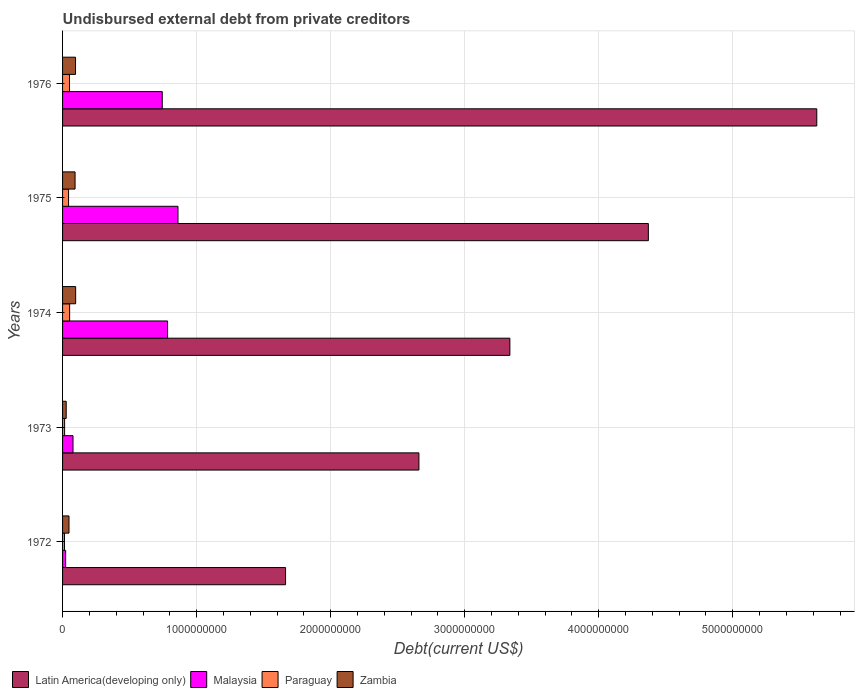Are the number of bars per tick equal to the number of legend labels?
Ensure brevity in your answer.  Yes. How many bars are there on the 3rd tick from the top?
Make the answer very short. 4. What is the label of the 4th group of bars from the top?
Make the answer very short. 1973. What is the total debt in Paraguay in 1976?
Your answer should be compact. 5.19e+07. Across all years, what is the maximum total debt in Malaysia?
Offer a terse response. 8.61e+08. Across all years, what is the minimum total debt in Malaysia?
Offer a very short reply. 2.31e+07. In which year was the total debt in Malaysia maximum?
Provide a succinct answer. 1975. In which year was the total debt in Zambia minimum?
Offer a terse response. 1973. What is the total total debt in Zambia in the graph?
Provide a succinct answer. 3.63e+08. What is the difference between the total debt in Malaysia in 1972 and that in 1975?
Keep it short and to the point. -8.38e+08. What is the difference between the total debt in Zambia in 1975 and the total debt in Paraguay in 1972?
Provide a short and direct response. 7.89e+07. What is the average total debt in Malaysia per year?
Provide a short and direct response. 4.98e+08. In the year 1976, what is the difference between the total debt in Malaysia and total debt in Zambia?
Give a very brief answer. 6.47e+08. In how many years, is the total debt in Paraguay greater than 3400000000 US$?
Provide a short and direct response. 0. What is the ratio of the total debt in Zambia in 1974 to that in 1975?
Make the answer very short. 1.05. Is the total debt in Paraguay in 1975 less than that in 1976?
Give a very brief answer. Yes. What is the difference between the highest and the second highest total debt in Paraguay?
Keep it short and to the point. 9.37e+05. What is the difference between the highest and the lowest total debt in Paraguay?
Provide a short and direct response. 3.85e+07. What does the 2nd bar from the top in 1975 represents?
Give a very brief answer. Paraguay. What does the 1st bar from the bottom in 1976 represents?
Your response must be concise. Latin America(developing only). Is it the case that in every year, the sum of the total debt in Malaysia and total debt in Paraguay is greater than the total debt in Zambia?
Offer a terse response. No. How many bars are there?
Your answer should be very brief. 20. Are the values on the major ticks of X-axis written in scientific E-notation?
Ensure brevity in your answer.  No. Where does the legend appear in the graph?
Your response must be concise. Bottom left. How many legend labels are there?
Your response must be concise. 4. How are the legend labels stacked?
Give a very brief answer. Horizontal. What is the title of the graph?
Provide a succinct answer. Undisbursed external debt from private creditors. What is the label or title of the X-axis?
Offer a very short reply. Debt(current US$). What is the Debt(current US$) in Latin America(developing only) in 1972?
Ensure brevity in your answer.  1.66e+09. What is the Debt(current US$) in Malaysia in 1972?
Your answer should be very brief. 2.31e+07. What is the Debt(current US$) in Paraguay in 1972?
Provide a succinct answer. 1.43e+07. What is the Debt(current US$) in Zambia in 1972?
Offer a terse response. 4.80e+07. What is the Debt(current US$) of Latin America(developing only) in 1973?
Offer a terse response. 2.66e+09. What is the Debt(current US$) of Malaysia in 1973?
Your answer should be very brief. 7.79e+07. What is the Debt(current US$) of Paraguay in 1973?
Your answer should be compact. 1.52e+07. What is the Debt(current US$) in Zambia in 1973?
Provide a succinct answer. 2.71e+07. What is the Debt(current US$) of Latin America(developing only) in 1974?
Your response must be concise. 3.34e+09. What is the Debt(current US$) in Malaysia in 1974?
Offer a terse response. 7.83e+08. What is the Debt(current US$) of Paraguay in 1974?
Offer a terse response. 5.28e+07. What is the Debt(current US$) of Zambia in 1974?
Provide a short and direct response. 9.76e+07. What is the Debt(current US$) in Latin America(developing only) in 1975?
Provide a short and direct response. 4.37e+09. What is the Debt(current US$) of Malaysia in 1975?
Your response must be concise. 8.61e+08. What is the Debt(current US$) in Paraguay in 1975?
Keep it short and to the point. 4.47e+07. What is the Debt(current US$) in Zambia in 1975?
Your answer should be compact. 9.32e+07. What is the Debt(current US$) in Latin America(developing only) in 1976?
Provide a succinct answer. 5.63e+09. What is the Debt(current US$) of Malaysia in 1976?
Provide a succinct answer. 7.44e+08. What is the Debt(current US$) in Paraguay in 1976?
Offer a terse response. 5.19e+07. What is the Debt(current US$) in Zambia in 1976?
Provide a short and direct response. 9.68e+07. Across all years, what is the maximum Debt(current US$) of Latin America(developing only)?
Your answer should be very brief. 5.63e+09. Across all years, what is the maximum Debt(current US$) in Malaysia?
Provide a short and direct response. 8.61e+08. Across all years, what is the maximum Debt(current US$) in Paraguay?
Make the answer very short. 5.28e+07. Across all years, what is the maximum Debt(current US$) of Zambia?
Give a very brief answer. 9.76e+07. Across all years, what is the minimum Debt(current US$) in Latin America(developing only)?
Provide a short and direct response. 1.66e+09. Across all years, what is the minimum Debt(current US$) in Malaysia?
Make the answer very short. 2.31e+07. Across all years, what is the minimum Debt(current US$) of Paraguay?
Provide a succinct answer. 1.43e+07. Across all years, what is the minimum Debt(current US$) of Zambia?
Make the answer very short. 2.71e+07. What is the total Debt(current US$) of Latin America(developing only) in the graph?
Offer a terse response. 1.77e+1. What is the total Debt(current US$) of Malaysia in the graph?
Your response must be concise. 2.49e+09. What is the total Debt(current US$) in Paraguay in the graph?
Keep it short and to the point. 1.79e+08. What is the total Debt(current US$) in Zambia in the graph?
Give a very brief answer. 3.63e+08. What is the difference between the Debt(current US$) in Latin America(developing only) in 1972 and that in 1973?
Provide a short and direct response. -9.95e+08. What is the difference between the Debt(current US$) in Malaysia in 1972 and that in 1973?
Your answer should be very brief. -5.49e+07. What is the difference between the Debt(current US$) of Paraguay in 1972 and that in 1973?
Offer a terse response. -8.94e+05. What is the difference between the Debt(current US$) of Zambia in 1972 and that in 1973?
Give a very brief answer. 2.08e+07. What is the difference between the Debt(current US$) in Latin America(developing only) in 1972 and that in 1974?
Ensure brevity in your answer.  -1.67e+09. What is the difference between the Debt(current US$) of Malaysia in 1972 and that in 1974?
Offer a very short reply. -7.60e+08. What is the difference between the Debt(current US$) in Paraguay in 1972 and that in 1974?
Offer a very short reply. -3.85e+07. What is the difference between the Debt(current US$) in Zambia in 1972 and that in 1974?
Your response must be concise. -4.96e+07. What is the difference between the Debt(current US$) of Latin America(developing only) in 1972 and that in 1975?
Offer a terse response. -2.71e+09. What is the difference between the Debt(current US$) of Malaysia in 1972 and that in 1975?
Give a very brief answer. -8.38e+08. What is the difference between the Debt(current US$) in Paraguay in 1972 and that in 1975?
Ensure brevity in your answer.  -3.04e+07. What is the difference between the Debt(current US$) of Zambia in 1972 and that in 1975?
Your response must be concise. -4.52e+07. What is the difference between the Debt(current US$) in Latin America(developing only) in 1972 and that in 1976?
Ensure brevity in your answer.  -3.96e+09. What is the difference between the Debt(current US$) in Malaysia in 1972 and that in 1976?
Keep it short and to the point. -7.21e+08. What is the difference between the Debt(current US$) of Paraguay in 1972 and that in 1976?
Provide a succinct answer. -3.75e+07. What is the difference between the Debt(current US$) of Zambia in 1972 and that in 1976?
Your response must be concise. -4.88e+07. What is the difference between the Debt(current US$) of Latin America(developing only) in 1973 and that in 1974?
Offer a terse response. -6.79e+08. What is the difference between the Debt(current US$) in Malaysia in 1973 and that in 1974?
Your answer should be compact. -7.06e+08. What is the difference between the Debt(current US$) of Paraguay in 1973 and that in 1974?
Make the answer very short. -3.76e+07. What is the difference between the Debt(current US$) in Zambia in 1973 and that in 1974?
Your answer should be very brief. -7.05e+07. What is the difference between the Debt(current US$) in Latin America(developing only) in 1973 and that in 1975?
Ensure brevity in your answer.  -1.71e+09. What is the difference between the Debt(current US$) of Malaysia in 1973 and that in 1975?
Your answer should be compact. -7.83e+08. What is the difference between the Debt(current US$) of Paraguay in 1973 and that in 1975?
Ensure brevity in your answer.  -2.95e+07. What is the difference between the Debt(current US$) of Zambia in 1973 and that in 1975?
Ensure brevity in your answer.  -6.61e+07. What is the difference between the Debt(current US$) of Latin America(developing only) in 1973 and that in 1976?
Provide a short and direct response. -2.97e+09. What is the difference between the Debt(current US$) in Malaysia in 1973 and that in 1976?
Make the answer very short. -6.66e+08. What is the difference between the Debt(current US$) of Paraguay in 1973 and that in 1976?
Offer a terse response. -3.66e+07. What is the difference between the Debt(current US$) in Zambia in 1973 and that in 1976?
Provide a short and direct response. -6.96e+07. What is the difference between the Debt(current US$) in Latin America(developing only) in 1974 and that in 1975?
Your response must be concise. -1.03e+09. What is the difference between the Debt(current US$) of Malaysia in 1974 and that in 1975?
Your answer should be very brief. -7.76e+07. What is the difference between the Debt(current US$) of Paraguay in 1974 and that in 1975?
Provide a succinct answer. 8.11e+06. What is the difference between the Debt(current US$) in Zambia in 1974 and that in 1975?
Provide a succinct answer. 4.40e+06. What is the difference between the Debt(current US$) of Latin America(developing only) in 1974 and that in 1976?
Give a very brief answer. -2.29e+09. What is the difference between the Debt(current US$) in Malaysia in 1974 and that in 1976?
Keep it short and to the point. 3.96e+07. What is the difference between the Debt(current US$) of Paraguay in 1974 and that in 1976?
Give a very brief answer. 9.37e+05. What is the difference between the Debt(current US$) of Zambia in 1974 and that in 1976?
Your answer should be very brief. 8.46e+05. What is the difference between the Debt(current US$) of Latin America(developing only) in 1975 and that in 1976?
Ensure brevity in your answer.  -1.26e+09. What is the difference between the Debt(current US$) of Malaysia in 1975 and that in 1976?
Your answer should be compact. 1.17e+08. What is the difference between the Debt(current US$) in Paraguay in 1975 and that in 1976?
Your answer should be compact. -7.18e+06. What is the difference between the Debt(current US$) of Zambia in 1975 and that in 1976?
Your answer should be very brief. -3.55e+06. What is the difference between the Debt(current US$) of Latin America(developing only) in 1972 and the Debt(current US$) of Malaysia in 1973?
Your answer should be very brief. 1.59e+09. What is the difference between the Debt(current US$) of Latin America(developing only) in 1972 and the Debt(current US$) of Paraguay in 1973?
Provide a short and direct response. 1.65e+09. What is the difference between the Debt(current US$) of Latin America(developing only) in 1972 and the Debt(current US$) of Zambia in 1973?
Your answer should be compact. 1.64e+09. What is the difference between the Debt(current US$) of Malaysia in 1972 and the Debt(current US$) of Paraguay in 1973?
Make the answer very short. 7.84e+06. What is the difference between the Debt(current US$) of Malaysia in 1972 and the Debt(current US$) of Zambia in 1973?
Provide a short and direct response. -4.05e+06. What is the difference between the Debt(current US$) of Paraguay in 1972 and the Debt(current US$) of Zambia in 1973?
Ensure brevity in your answer.  -1.28e+07. What is the difference between the Debt(current US$) of Latin America(developing only) in 1972 and the Debt(current US$) of Malaysia in 1974?
Give a very brief answer. 8.80e+08. What is the difference between the Debt(current US$) in Latin America(developing only) in 1972 and the Debt(current US$) in Paraguay in 1974?
Offer a terse response. 1.61e+09. What is the difference between the Debt(current US$) in Latin America(developing only) in 1972 and the Debt(current US$) in Zambia in 1974?
Ensure brevity in your answer.  1.57e+09. What is the difference between the Debt(current US$) of Malaysia in 1972 and the Debt(current US$) of Paraguay in 1974?
Keep it short and to the point. -2.97e+07. What is the difference between the Debt(current US$) of Malaysia in 1972 and the Debt(current US$) of Zambia in 1974?
Offer a very short reply. -7.45e+07. What is the difference between the Debt(current US$) of Paraguay in 1972 and the Debt(current US$) of Zambia in 1974?
Offer a terse response. -8.33e+07. What is the difference between the Debt(current US$) in Latin America(developing only) in 1972 and the Debt(current US$) in Malaysia in 1975?
Give a very brief answer. 8.03e+08. What is the difference between the Debt(current US$) of Latin America(developing only) in 1972 and the Debt(current US$) of Paraguay in 1975?
Give a very brief answer. 1.62e+09. What is the difference between the Debt(current US$) of Latin America(developing only) in 1972 and the Debt(current US$) of Zambia in 1975?
Offer a very short reply. 1.57e+09. What is the difference between the Debt(current US$) in Malaysia in 1972 and the Debt(current US$) in Paraguay in 1975?
Your answer should be very brief. -2.16e+07. What is the difference between the Debt(current US$) in Malaysia in 1972 and the Debt(current US$) in Zambia in 1975?
Offer a very short reply. -7.01e+07. What is the difference between the Debt(current US$) of Paraguay in 1972 and the Debt(current US$) of Zambia in 1975?
Give a very brief answer. -7.89e+07. What is the difference between the Debt(current US$) of Latin America(developing only) in 1972 and the Debt(current US$) of Malaysia in 1976?
Keep it short and to the point. 9.20e+08. What is the difference between the Debt(current US$) in Latin America(developing only) in 1972 and the Debt(current US$) in Paraguay in 1976?
Provide a succinct answer. 1.61e+09. What is the difference between the Debt(current US$) of Latin America(developing only) in 1972 and the Debt(current US$) of Zambia in 1976?
Your response must be concise. 1.57e+09. What is the difference between the Debt(current US$) in Malaysia in 1972 and the Debt(current US$) in Paraguay in 1976?
Provide a succinct answer. -2.88e+07. What is the difference between the Debt(current US$) of Malaysia in 1972 and the Debt(current US$) of Zambia in 1976?
Your answer should be compact. -7.37e+07. What is the difference between the Debt(current US$) in Paraguay in 1972 and the Debt(current US$) in Zambia in 1976?
Your answer should be compact. -8.24e+07. What is the difference between the Debt(current US$) of Latin America(developing only) in 1973 and the Debt(current US$) of Malaysia in 1974?
Offer a terse response. 1.88e+09. What is the difference between the Debt(current US$) in Latin America(developing only) in 1973 and the Debt(current US$) in Paraguay in 1974?
Ensure brevity in your answer.  2.61e+09. What is the difference between the Debt(current US$) of Latin America(developing only) in 1973 and the Debt(current US$) of Zambia in 1974?
Keep it short and to the point. 2.56e+09. What is the difference between the Debt(current US$) in Malaysia in 1973 and the Debt(current US$) in Paraguay in 1974?
Ensure brevity in your answer.  2.51e+07. What is the difference between the Debt(current US$) of Malaysia in 1973 and the Debt(current US$) of Zambia in 1974?
Provide a succinct answer. -1.97e+07. What is the difference between the Debt(current US$) of Paraguay in 1973 and the Debt(current US$) of Zambia in 1974?
Your response must be concise. -8.24e+07. What is the difference between the Debt(current US$) of Latin America(developing only) in 1973 and the Debt(current US$) of Malaysia in 1975?
Provide a short and direct response. 1.80e+09. What is the difference between the Debt(current US$) of Latin America(developing only) in 1973 and the Debt(current US$) of Paraguay in 1975?
Provide a short and direct response. 2.61e+09. What is the difference between the Debt(current US$) in Latin America(developing only) in 1973 and the Debt(current US$) in Zambia in 1975?
Offer a very short reply. 2.57e+09. What is the difference between the Debt(current US$) of Malaysia in 1973 and the Debt(current US$) of Paraguay in 1975?
Offer a terse response. 3.32e+07. What is the difference between the Debt(current US$) in Malaysia in 1973 and the Debt(current US$) in Zambia in 1975?
Your response must be concise. -1.53e+07. What is the difference between the Debt(current US$) in Paraguay in 1973 and the Debt(current US$) in Zambia in 1975?
Provide a short and direct response. -7.80e+07. What is the difference between the Debt(current US$) of Latin America(developing only) in 1973 and the Debt(current US$) of Malaysia in 1976?
Keep it short and to the point. 1.91e+09. What is the difference between the Debt(current US$) of Latin America(developing only) in 1973 and the Debt(current US$) of Paraguay in 1976?
Give a very brief answer. 2.61e+09. What is the difference between the Debt(current US$) of Latin America(developing only) in 1973 and the Debt(current US$) of Zambia in 1976?
Provide a succinct answer. 2.56e+09. What is the difference between the Debt(current US$) in Malaysia in 1973 and the Debt(current US$) in Paraguay in 1976?
Ensure brevity in your answer.  2.61e+07. What is the difference between the Debt(current US$) of Malaysia in 1973 and the Debt(current US$) of Zambia in 1976?
Offer a terse response. -1.88e+07. What is the difference between the Debt(current US$) in Paraguay in 1973 and the Debt(current US$) in Zambia in 1976?
Offer a terse response. -8.15e+07. What is the difference between the Debt(current US$) of Latin America(developing only) in 1974 and the Debt(current US$) of Malaysia in 1975?
Ensure brevity in your answer.  2.48e+09. What is the difference between the Debt(current US$) of Latin America(developing only) in 1974 and the Debt(current US$) of Paraguay in 1975?
Keep it short and to the point. 3.29e+09. What is the difference between the Debt(current US$) of Latin America(developing only) in 1974 and the Debt(current US$) of Zambia in 1975?
Your answer should be compact. 3.24e+09. What is the difference between the Debt(current US$) of Malaysia in 1974 and the Debt(current US$) of Paraguay in 1975?
Ensure brevity in your answer.  7.39e+08. What is the difference between the Debt(current US$) of Malaysia in 1974 and the Debt(current US$) of Zambia in 1975?
Make the answer very short. 6.90e+08. What is the difference between the Debt(current US$) of Paraguay in 1974 and the Debt(current US$) of Zambia in 1975?
Offer a very short reply. -4.04e+07. What is the difference between the Debt(current US$) of Latin America(developing only) in 1974 and the Debt(current US$) of Malaysia in 1976?
Give a very brief answer. 2.59e+09. What is the difference between the Debt(current US$) in Latin America(developing only) in 1974 and the Debt(current US$) in Paraguay in 1976?
Provide a succinct answer. 3.29e+09. What is the difference between the Debt(current US$) in Latin America(developing only) in 1974 and the Debt(current US$) in Zambia in 1976?
Give a very brief answer. 3.24e+09. What is the difference between the Debt(current US$) of Malaysia in 1974 and the Debt(current US$) of Paraguay in 1976?
Make the answer very short. 7.32e+08. What is the difference between the Debt(current US$) in Malaysia in 1974 and the Debt(current US$) in Zambia in 1976?
Provide a succinct answer. 6.87e+08. What is the difference between the Debt(current US$) in Paraguay in 1974 and the Debt(current US$) in Zambia in 1976?
Make the answer very short. -4.40e+07. What is the difference between the Debt(current US$) of Latin America(developing only) in 1975 and the Debt(current US$) of Malaysia in 1976?
Provide a short and direct response. 3.63e+09. What is the difference between the Debt(current US$) of Latin America(developing only) in 1975 and the Debt(current US$) of Paraguay in 1976?
Give a very brief answer. 4.32e+09. What is the difference between the Debt(current US$) of Latin America(developing only) in 1975 and the Debt(current US$) of Zambia in 1976?
Make the answer very short. 4.27e+09. What is the difference between the Debt(current US$) of Malaysia in 1975 and the Debt(current US$) of Paraguay in 1976?
Keep it short and to the point. 8.09e+08. What is the difference between the Debt(current US$) of Malaysia in 1975 and the Debt(current US$) of Zambia in 1976?
Provide a short and direct response. 7.64e+08. What is the difference between the Debt(current US$) in Paraguay in 1975 and the Debt(current US$) in Zambia in 1976?
Give a very brief answer. -5.21e+07. What is the average Debt(current US$) of Latin America(developing only) per year?
Your response must be concise. 3.53e+09. What is the average Debt(current US$) in Malaysia per year?
Your answer should be very brief. 4.98e+08. What is the average Debt(current US$) of Paraguay per year?
Your response must be concise. 3.58e+07. What is the average Debt(current US$) of Zambia per year?
Offer a very short reply. 7.25e+07. In the year 1972, what is the difference between the Debt(current US$) in Latin America(developing only) and Debt(current US$) in Malaysia?
Make the answer very short. 1.64e+09. In the year 1972, what is the difference between the Debt(current US$) in Latin America(developing only) and Debt(current US$) in Paraguay?
Provide a succinct answer. 1.65e+09. In the year 1972, what is the difference between the Debt(current US$) of Latin America(developing only) and Debt(current US$) of Zambia?
Give a very brief answer. 1.62e+09. In the year 1972, what is the difference between the Debt(current US$) of Malaysia and Debt(current US$) of Paraguay?
Your answer should be very brief. 8.74e+06. In the year 1972, what is the difference between the Debt(current US$) of Malaysia and Debt(current US$) of Zambia?
Give a very brief answer. -2.49e+07. In the year 1972, what is the difference between the Debt(current US$) in Paraguay and Debt(current US$) in Zambia?
Ensure brevity in your answer.  -3.36e+07. In the year 1973, what is the difference between the Debt(current US$) in Latin America(developing only) and Debt(current US$) in Malaysia?
Your answer should be compact. 2.58e+09. In the year 1973, what is the difference between the Debt(current US$) of Latin America(developing only) and Debt(current US$) of Paraguay?
Provide a short and direct response. 2.64e+09. In the year 1973, what is the difference between the Debt(current US$) in Latin America(developing only) and Debt(current US$) in Zambia?
Your answer should be very brief. 2.63e+09. In the year 1973, what is the difference between the Debt(current US$) in Malaysia and Debt(current US$) in Paraguay?
Provide a succinct answer. 6.27e+07. In the year 1973, what is the difference between the Debt(current US$) in Malaysia and Debt(current US$) in Zambia?
Give a very brief answer. 5.08e+07. In the year 1973, what is the difference between the Debt(current US$) in Paraguay and Debt(current US$) in Zambia?
Provide a short and direct response. -1.19e+07. In the year 1974, what is the difference between the Debt(current US$) in Latin America(developing only) and Debt(current US$) in Malaysia?
Give a very brief answer. 2.55e+09. In the year 1974, what is the difference between the Debt(current US$) in Latin America(developing only) and Debt(current US$) in Paraguay?
Your answer should be compact. 3.28e+09. In the year 1974, what is the difference between the Debt(current US$) of Latin America(developing only) and Debt(current US$) of Zambia?
Make the answer very short. 3.24e+09. In the year 1974, what is the difference between the Debt(current US$) of Malaysia and Debt(current US$) of Paraguay?
Make the answer very short. 7.31e+08. In the year 1974, what is the difference between the Debt(current US$) in Malaysia and Debt(current US$) in Zambia?
Your answer should be compact. 6.86e+08. In the year 1974, what is the difference between the Debt(current US$) in Paraguay and Debt(current US$) in Zambia?
Give a very brief answer. -4.48e+07. In the year 1975, what is the difference between the Debt(current US$) of Latin America(developing only) and Debt(current US$) of Malaysia?
Give a very brief answer. 3.51e+09. In the year 1975, what is the difference between the Debt(current US$) in Latin America(developing only) and Debt(current US$) in Paraguay?
Your answer should be very brief. 4.33e+09. In the year 1975, what is the difference between the Debt(current US$) of Latin America(developing only) and Debt(current US$) of Zambia?
Provide a succinct answer. 4.28e+09. In the year 1975, what is the difference between the Debt(current US$) of Malaysia and Debt(current US$) of Paraguay?
Offer a terse response. 8.16e+08. In the year 1975, what is the difference between the Debt(current US$) of Malaysia and Debt(current US$) of Zambia?
Offer a terse response. 7.68e+08. In the year 1975, what is the difference between the Debt(current US$) in Paraguay and Debt(current US$) in Zambia?
Give a very brief answer. -4.85e+07. In the year 1976, what is the difference between the Debt(current US$) in Latin America(developing only) and Debt(current US$) in Malaysia?
Keep it short and to the point. 4.88e+09. In the year 1976, what is the difference between the Debt(current US$) in Latin America(developing only) and Debt(current US$) in Paraguay?
Give a very brief answer. 5.57e+09. In the year 1976, what is the difference between the Debt(current US$) in Latin America(developing only) and Debt(current US$) in Zambia?
Give a very brief answer. 5.53e+09. In the year 1976, what is the difference between the Debt(current US$) of Malaysia and Debt(current US$) of Paraguay?
Give a very brief answer. 6.92e+08. In the year 1976, what is the difference between the Debt(current US$) in Malaysia and Debt(current US$) in Zambia?
Provide a short and direct response. 6.47e+08. In the year 1976, what is the difference between the Debt(current US$) in Paraguay and Debt(current US$) in Zambia?
Your answer should be compact. -4.49e+07. What is the ratio of the Debt(current US$) in Latin America(developing only) in 1972 to that in 1973?
Your answer should be very brief. 0.63. What is the ratio of the Debt(current US$) in Malaysia in 1972 to that in 1973?
Provide a succinct answer. 0.3. What is the ratio of the Debt(current US$) in Paraguay in 1972 to that in 1973?
Provide a succinct answer. 0.94. What is the ratio of the Debt(current US$) of Zambia in 1972 to that in 1973?
Offer a terse response. 1.77. What is the ratio of the Debt(current US$) in Latin America(developing only) in 1972 to that in 1974?
Your answer should be very brief. 0.5. What is the ratio of the Debt(current US$) in Malaysia in 1972 to that in 1974?
Your response must be concise. 0.03. What is the ratio of the Debt(current US$) of Paraguay in 1972 to that in 1974?
Offer a terse response. 0.27. What is the ratio of the Debt(current US$) of Zambia in 1972 to that in 1974?
Your answer should be compact. 0.49. What is the ratio of the Debt(current US$) of Latin America(developing only) in 1972 to that in 1975?
Ensure brevity in your answer.  0.38. What is the ratio of the Debt(current US$) of Malaysia in 1972 to that in 1975?
Make the answer very short. 0.03. What is the ratio of the Debt(current US$) of Paraguay in 1972 to that in 1975?
Offer a terse response. 0.32. What is the ratio of the Debt(current US$) in Zambia in 1972 to that in 1975?
Give a very brief answer. 0.51. What is the ratio of the Debt(current US$) in Latin America(developing only) in 1972 to that in 1976?
Your response must be concise. 0.3. What is the ratio of the Debt(current US$) in Malaysia in 1972 to that in 1976?
Your response must be concise. 0.03. What is the ratio of the Debt(current US$) in Paraguay in 1972 to that in 1976?
Keep it short and to the point. 0.28. What is the ratio of the Debt(current US$) in Zambia in 1972 to that in 1976?
Provide a succinct answer. 0.5. What is the ratio of the Debt(current US$) of Latin America(developing only) in 1973 to that in 1974?
Your response must be concise. 0.8. What is the ratio of the Debt(current US$) in Malaysia in 1973 to that in 1974?
Offer a terse response. 0.1. What is the ratio of the Debt(current US$) in Paraguay in 1973 to that in 1974?
Keep it short and to the point. 0.29. What is the ratio of the Debt(current US$) in Zambia in 1973 to that in 1974?
Provide a short and direct response. 0.28. What is the ratio of the Debt(current US$) of Latin America(developing only) in 1973 to that in 1975?
Provide a short and direct response. 0.61. What is the ratio of the Debt(current US$) in Malaysia in 1973 to that in 1975?
Provide a succinct answer. 0.09. What is the ratio of the Debt(current US$) in Paraguay in 1973 to that in 1975?
Offer a very short reply. 0.34. What is the ratio of the Debt(current US$) of Zambia in 1973 to that in 1975?
Provide a succinct answer. 0.29. What is the ratio of the Debt(current US$) in Latin America(developing only) in 1973 to that in 1976?
Your answer should be compact. 0.47. What is the ratio of the Debt(current US$) of Malaysia in 1973 to that in 1976?
Provide a short and direct response. 0.1. What is the ratio of the Debt(current US$) in Paraguay in 1973 to that in 1976?
Give a very brief answer. 0.29. What is the ratio of the Debt(current US$) in Zambia in 1973 to that in 1976?
Provide a succinct answer. 0.28. What is the ratio of the Debt(current US$) in Latin America(developing only) in 1974 to that in 1975?
Ensure brevity in your answer.  0.76. What is the ratio of the Debt(current US$) in Malaysia in 1974 to that in 1975?
Ensure brevity in your answer.  0.91. What is the ratio of the Debt(current US$) in Paraguay in 1974 to that in 1975?
Your answer should be compact. 1.18. What is the ratio of the Debt(current US$) of Zambia in 1974 to that in 1975?
Provide a short and direct response. 1.05. What is the ratio of the Debt(current US$) of Latin America(developing only) in 1974 to that in 1976?
Offer a very short reply. 0.59. What is the ratio of the Debt(current US$) in Malaysia in 1974 to that in 1976?
Offer a terse response. 1.05. What is the ratio of the Debt(current US$) in Paraguay in 1974 to that in 1976?
Offer a terse response. 1.02. What is the ratio of the Debt(current US$) of Zambia in 1974 to that in 1976?
Your answer should be compact. 1.01. What is the ratio of the Debt(current US$) of Latin America(developing only) in 1975 to that in 1976?
Keep it short and to the point. 0.78. What is the ratio of the Debt(current US$) in Malaysia in 1975 to that in 1976?
Provide a succinct answer. 1.16. What is the ratio of the Debt(current US$) in Paraguay in 1975 to that in 1976?
Your answer should be compact. 0.86. What is the ratio of the Debt(current US$) in Zambia in 1975 to that in 1976?
Your answer should be very brief. 0.96. What is the difference between the highest and the second highest Debt(current US$) of Latin America(developing only)?
Give a very brief answer. 1.26e+09. What is the difference between the highest and the second highest Debt(current US$) in Malaysia?
Your answer should be very brief. 7.76e+07. What is the difference between the highest and the second highest Debt(current US$) of Paraguay?
Offer a very short reply. 9.37e+05. What is the difference between the highest and the second highest Debt(current US$) of Zambia?
Your response must be concise. 8.46e+05. What is the difference between the highest and the lowest Debt(current US$) in Latin America(developing only)?
Make the answer very short. 3.96e+09. What is the difference between the highest and the lowest Debt(current US$) of Malaysia?
Provide a short and direct response. 8.38e+08. What is the difference between the highest and the lowest Debt(current US$) in Paraguay?
Your answer should be very brief. 3.85e+07. What is the difference between the highest and the lowest Debt(current US$) in Zambia?
Give a very brief answer. 7.05e+07. 